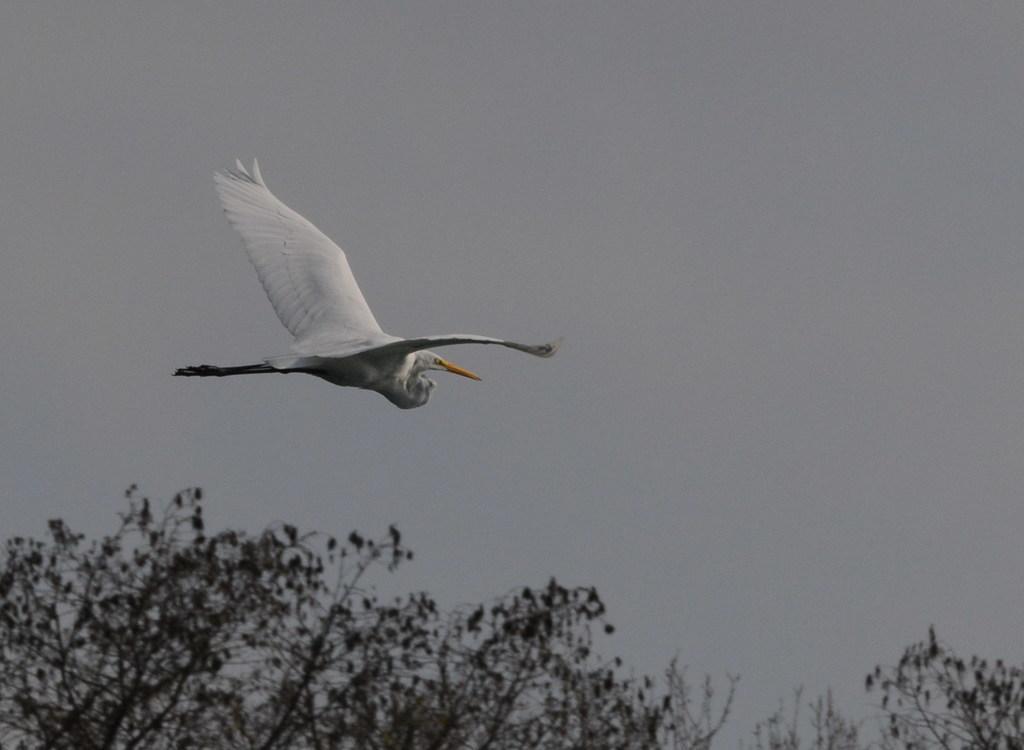How would you summarize this image in a sentence or two? In this image we can see a white color bird flying in the sky, and there are some trees. 